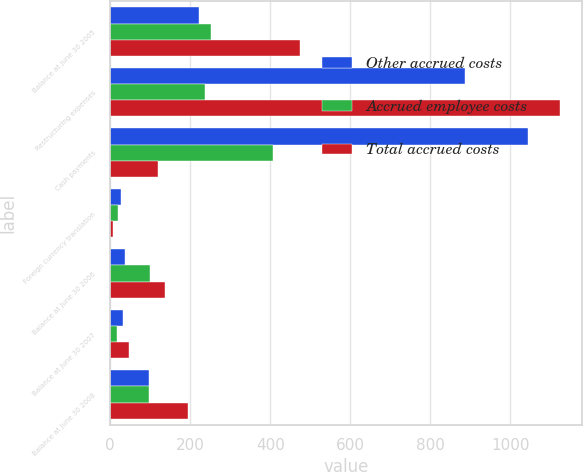Convert chart. <chart><loc_0><loc_0><loc_500><loc_500><stacked_bar_chart><ecel><fcel>Balance at June 30 2005<fcel>Restructuring expenses<fcel>Cash payments<fcel>Foreign currency translation<fcel>Balance at June 30 2006<fcel>Balance at June 30 2007<fcel>Balance at June 30 2008<nl><fcel>Other accrued costs<fcel>222<fcel>888<fcel>1044<fcel>28<fcel>38<fcel>32<fcel>97<nl><fcel>Accrued employee costs<fcel>252<fcel>236<fcel>408<fcel>20<fcel>100<fcel>16<fcel>98<nl><fcel>Total accrued costs<fcel>474<fcel>1124<fcel>119<fcel>8<fcel>138<fcel>48<fcel>195<nl></chart> 